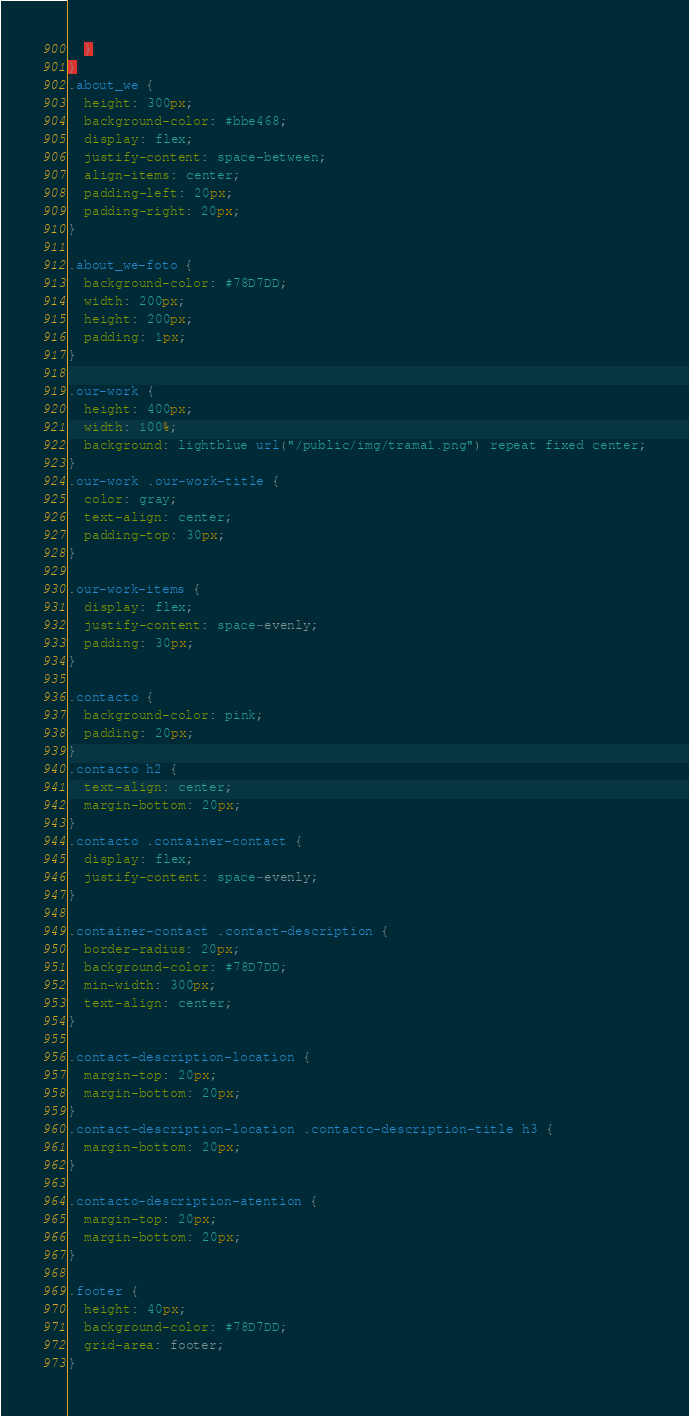<code> <loc_0><loc_0><loc_500><loc_500><_CSS_>  }
}
.about_we {
  height: 300px;
  background-color: #bbe468;
  display: flex;
  justify-content: space-between;
  align-items: center;
  padding-left: 20px;
  padding-right: 20px;
}

.about_we-foto {
  background-color: #78D7DD;
  width: 200px;
  height: 200px;
  padding: 1px;
}

.our-work {
  height: 400px;
  width: 100%;
  background: lightblue url("/public/img/trama1.png") repeat fixed center;
}
.our-work .our-work-title {
  color: gray;
  text-align: center;
  padding-top: 30px;
}

.our-work-items {
  display: flex;
  justify-content: space-evenly;
  padding: 30px;
}

.contacto {
  background-color: pink;
  padding: 20px;
}
.contacto h2 {
  text-align: center;
  margin-bottom: 20px;
}
.contacto .container-contact {
  display: flex;
  justify-content: space-evenly;
}

.container-contact .contact-description {
  border-radius: 20px;
  background-color: #78D7DD;
  min-width: 300px;
  text-align: center;
}

.contact-description-location {
  margin-top: 20px;
  margin-bottom: 20px;
}
.contact-description-location .contacto-description-title h3 {
  margin-bottom: 20px;
}

.contacto-description-atention {
  margin-top: 20px;
  margin-bottom: 20px;
}

.footer {
  height: 40px;
  background-color: #78D7DD;
  grid-area: footer;
}</code> 